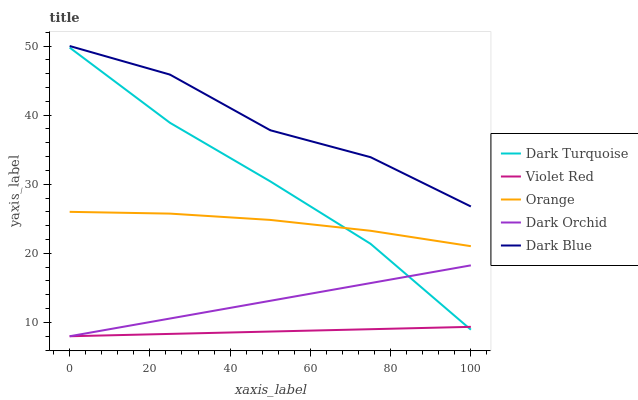Does Violet Red have the minimum area under the curve?
Answer yes or no. Yes. Does Dark Blue have the maximum area under the curve?
Answer yes or no. Yes. Does Dark Turquoise have the minimum area under the curve?
Answer yes or no. No. Does Dark Turquoise have the maximum area under the curve?
Answer yes or no. No. Is Violet Red the smoothest?
Answer yes or no. Yes. Is Dark Blue the roughest?
Answer yes or no. Yes. Is Dark Turquoise the smoothest?
Answer yes or no. No. Is Dark Turquoise the roughest?
Answer yes or no. No. Does Violet Red have the lowest value?
Answer yes or no. Yes. Does Dark Turquoise have the lowest value?
Answer yes or no. No. Does Dark Blue have the highest value?
Answer yes or no. Yes. Does Dark Turquoise have the highest value?
Answer yes or no. No. Is Dark Turquoise less than Dark Blue?
Answer yes or no. Yes. Is Orange greater than Violet Red?
Answer yes or no. Yes. Does Dark Turquoise intersect Dark Orchid?
Answer yes or no. Yes. Is Dark Turquoise less than Dark Orchid?
Answer yes or no. No. Is Dark Turquoise greater than Dark Orchid?
Answer yes or no. No. Does Dark Turquoise intersect Dark Blue?
Answer yes or no. No. 